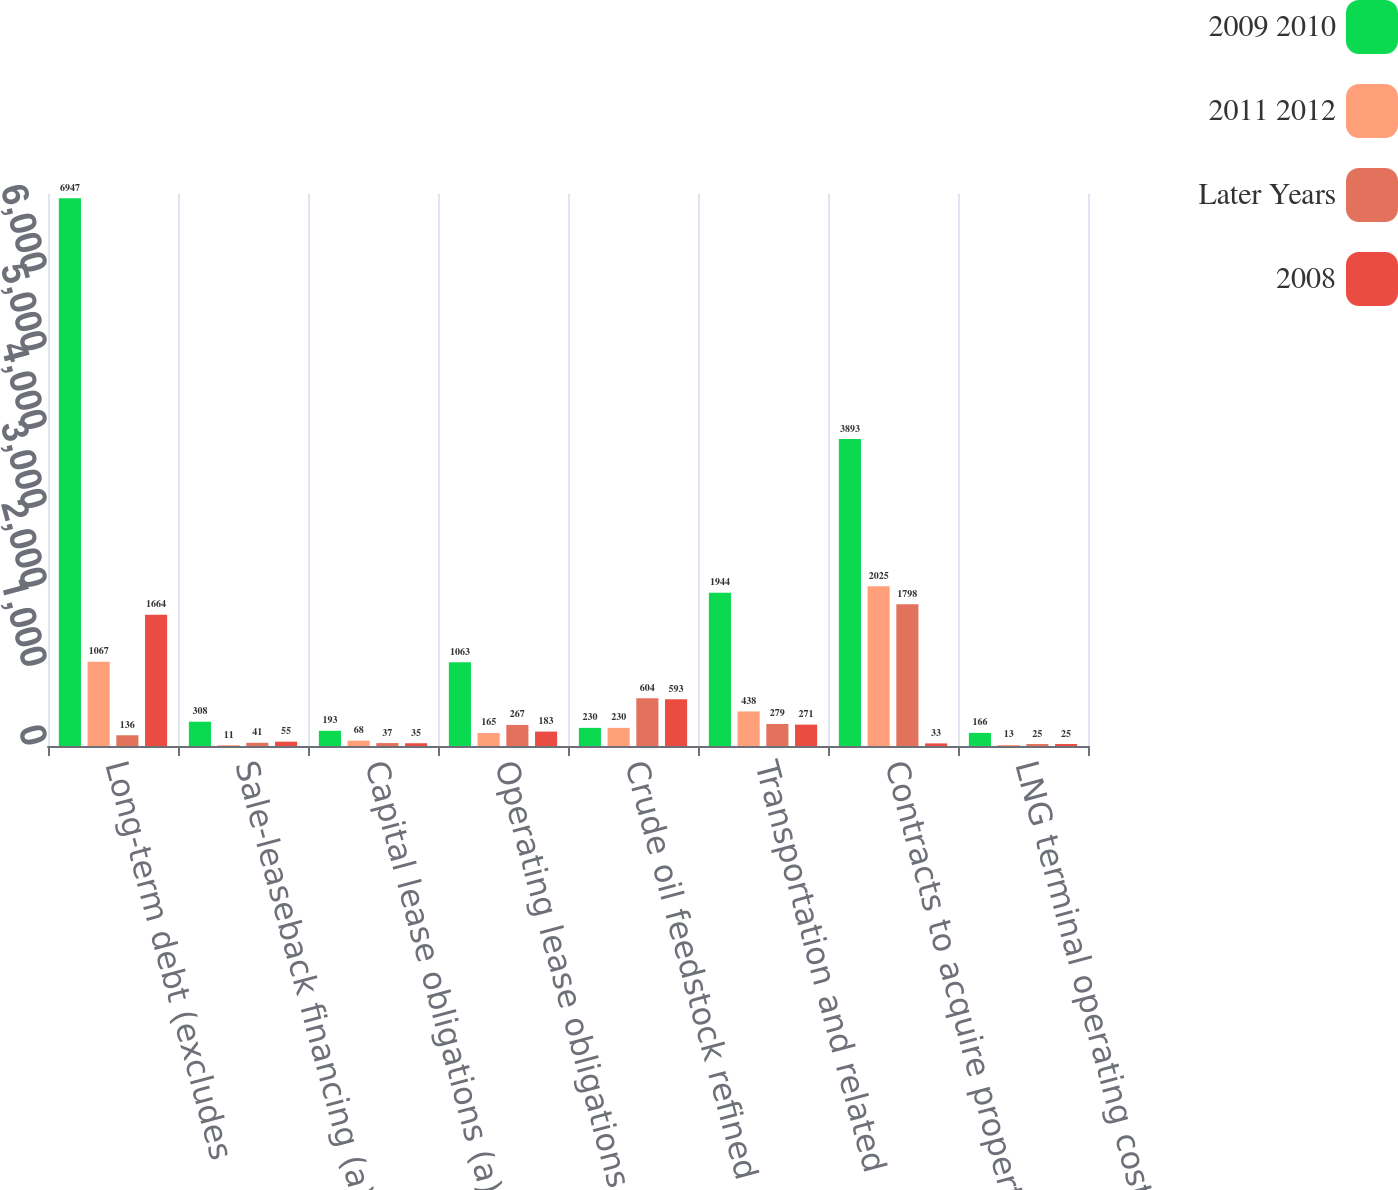Convert chart to OTSL. <chart><loc_0><loc_0><loc_500><loc_500><stacked_bar_chart><ecel><fcel>Long-term debt (excludes<fcel>Sale-leaseback financing (a)<fcel>Capital lease obligations (a)<fcel>Operating lease obligations<fcel>Crude oil feedstock refined<fcel>Transportation and related<fcel>Contracts to acquire property<fcel>LNG terminal operating costs<nl><fcel>2009 2010<fcel>6947<fcel>308<fcel>193<fcel>1063<fcel>230<fcel>1944<fcel>3893<fcel>166<nl><fcel>2011 2012<fcel>1067<fcel>11<fcel>68<fcel>165<fcel>230<fcel>438<fcel>2025<fcel>13<nl><fcel>Later Years<fcel>136<fcel>41<fcel>37<fcel>267<fcel>604<fcel>279<fcel>1798<fcel>25<nl><fcel>2008<fcel>1664<fcel>55<fcel>35<fcel>183<fcel>593<fcel>271<fcel>33<fcel>25<nl></chart> 